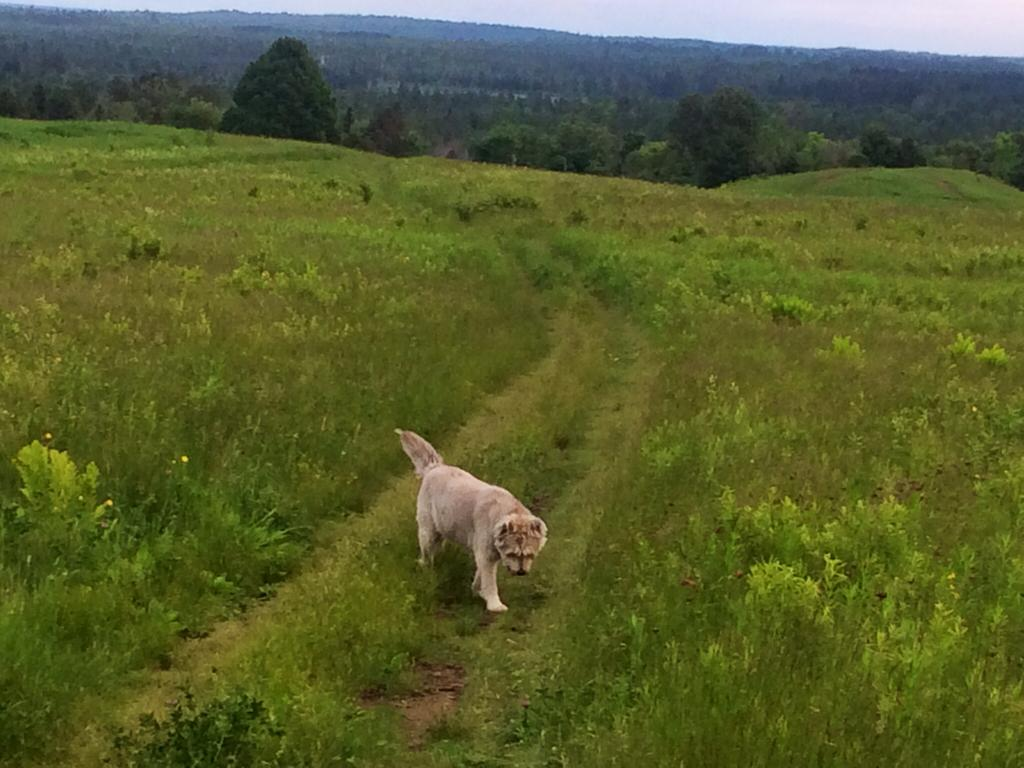What is the main subject in the center of the image? There is a dog in the center of the image. What type of surface is visible in the background of the image? There is grass on the ground in the background of the image. What other natural elements can be seen in the background of the image? There are trees in the background of the image. What is the texture of the aftermath in the image? There is no aftermath present in the image, so it is not possible to determine its texture. 